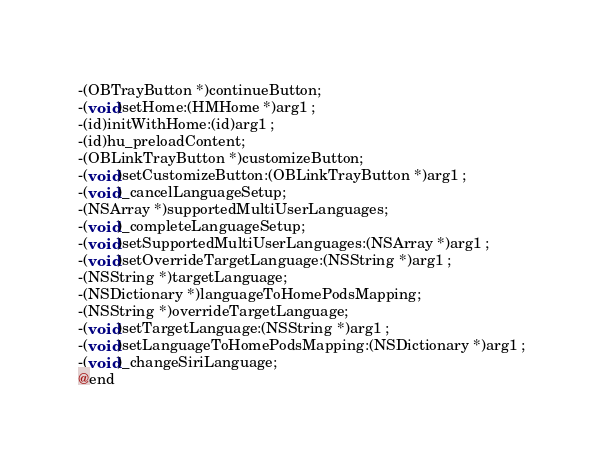Convert code to text. <code><loc_0><loc_0><loc_500><loc_500><_C_>-(OBTrayButton *)continueButton;
-(void)setHome:(HMHome *)arg1 ;
-(id)initWithHome:(id)arg1 ;
-(id)hu_preloadContent;
-(OBLinkTrayButton *)customizeButton;
-(void)setCustomizeButton:(OBLinkTrayButton *)arg1 ;
-(void)_cancelLanguageSetup;
-(NSArray *)supportedMultiUserLanguages;
-(void)_completeLanguageSetup;
-(void)setSupportedMultiUserLanguages:(NSArray *)arg1 ;
-(void)setOverrideTargetLanguage:(NSString *)arg1 ;
-(NSString *)targetLanguage;
-(NSDictionary *)languageToHomePodsMapping;
-(NSString *)overrideTargetLanguage;
-(void)setTargetLanguage:(NSString *)arg1 ;
-(void)setLanguageToHomePodsMapping:(NSDictionary *)arg1 ;
-(void)_changeSiriLanguage;
@end

</code> 